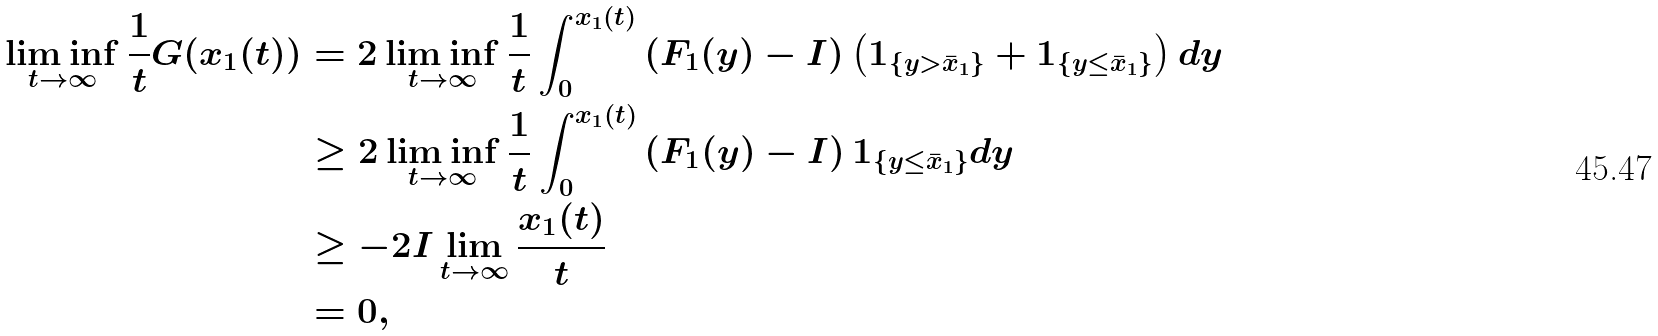<formula> <loc_0><loc_0><loc_500><loc_500>\liminf _ { t \to \infty } \frac { 1 } { t } G ( x _ { 1 } ( t ) ) & = 2 \liminf _ { t \to \infty } \frac { 1 } { t } \int _ { 0 } ^ { x _ { 1 } ( t ) } \left ( F _ { 1 } ( y ) - I \right ) \left ( 1 _ { \{ y > \bar { x } _ { 1 } \} } + 1 _ { \{ y \leq \bar { x } _ { 1 } \} } \right ) d y \\ & \geq 2 \liminf _ { t \to \infty } \frac { 1 } { t } \int _ { 0 } ^ { x _ { 1 } ( t ) } \left ( F _ { 1 } ( y ) - I \right ) 1 _ { \{ y \leq \bar { x } _ { 1 } \} } d y \\ & \geq - 2 I \lim _ { t \to \infty } \frac { x _ { 1 } ( t ) } { t } \\ & = 0 ,</formula> 